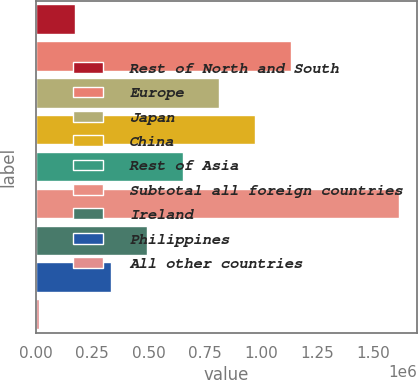Convert chart. <chart><loc_0><loc_0><loc_500><loc_500><bar_chart><fcel>Rest of North and South<fcel>Europe<fcel>Japan<fcel>China<fcel>Rest of Asia<fcel>Subtotal all foreign countries<fcel>Ireland<fcel>Philippines<fcel>All other countries<nl><fcel>173139<fcel>1.13325e+06<fcel>813210<fcel>973228<fcel>653193<fcel>1.6133e+06<fcel>493175<fcel>333157<fcel>13121<nl></chart> 